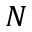<formula> <loc_0><loc_0><loc_500><loc_500>N</formula> 